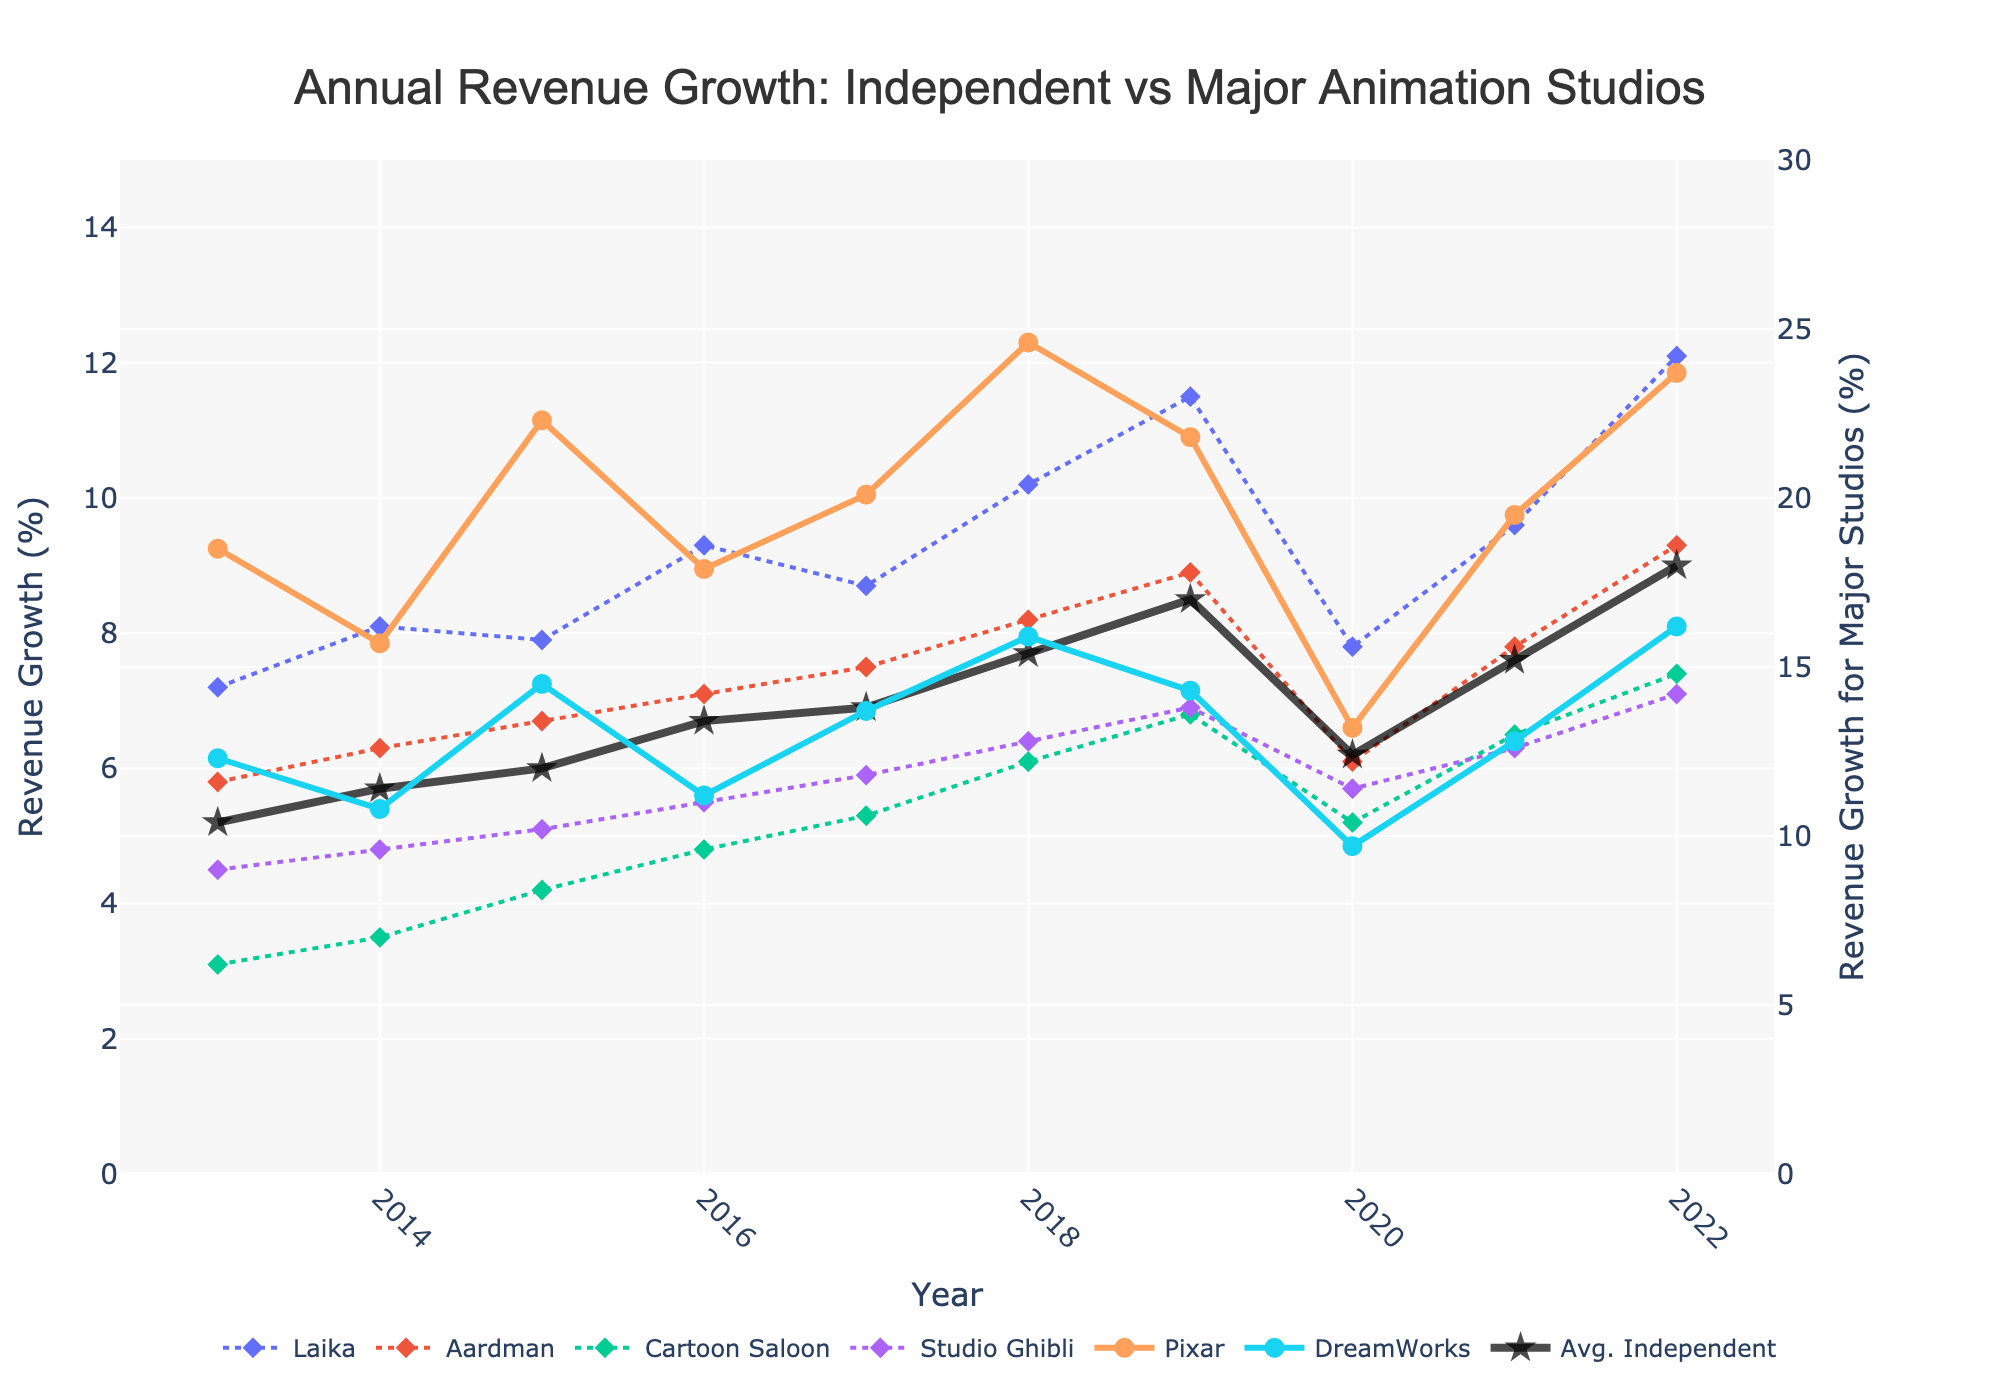How did the revenue growth for Pixar change from 2013 to 2022? To see the change in revenue growth for Pixar from 2013 to 2022, look at the starting point in 2013 (18.5%) and the ending point in 2022 (23.7%). Subtract the former from the latter: 23.7 - 18.5 = 5.2%.
Answer: 5.2% Which major studio had a higher revenue growth in 2019, Pixar or DreamWorks? Compare the revenue growth percentage for Pixar and DreamWorks in 2019. Pixar had 21.8% and DreamWorks had 14.3%. Therefore, Pixar had a higher revenue growth.
Answer: Pixar On average, how much did the revenue growth of independent studios increase from 2013 to 2022? Look at the average revenue growth of independent studios in 2013 (5.2%) and 2022 (9.0%). Calculate the increase: 9.0 - 5.2 = 3.8%.
Answer: 3.8% What year did Cartoon Saloon experience the highest revenue growth? Identify the peak value for Cartoon Saloon in the chart, which is in the year 2022 with a growth of 7.4%.
Answer: 2022 How many years did DreamWorks have a revenue growth of above 14%? Check the years where DreamWorks' revenue growth was above 14%. This occurred in 2015 (14.5%), 2018 (15.9%), and 2022 (16.2%), which totals to 3 years.
Answer: 3 years In which year did Laika's revenue growth fall below the average revenue growth of independent studios? Compare the yearly revenue growth of Laika with the average independent studios. Laika's growth fell below the average in 2013 (7.2% vs 5.2%), 2014 (8.1% vs 5.7%), and 2015 (7.9% vs 6.0%).
Answer: 2013, 2014, 2015 Which studio had the lowest revenue growth in 2014, and what was that value? Find the lowest value on the chart for 2014 for all studios. Cartoon Saloon had the lowest at 3.5%.
Answer: Cartoon Saloon, 3.5% Between 2017 and 2019, which independent studio showed the most significant increase in revenue growth? Calculate the increase for each independent studio between 2017 and 2019: Laika (8.7 to 11.5), Aardman (7.5 to 8.9), Cartoon Saloon (5.3 to 6.8), Studio Ghibli (5.9 to 6.9). Laika showed the largest increase (11.5 - 8.7 = 2.8).
Answer: Laika What visual attribute distinguishes independent studios from major studios on the graph? Look for a common visual characteristic among independent studios. Independent studios use diamond markers and dashed lines, while major studios use circular markers and solid lines.
Answer: diamond markers and dashed lines 